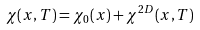<formula> <loc_0><loc_0><loc_500><loc_500>\chi ( x , T ) = \chi _ { 0 } ( x ) + \chi ^ { 2 D } ( x , T )</formula> 